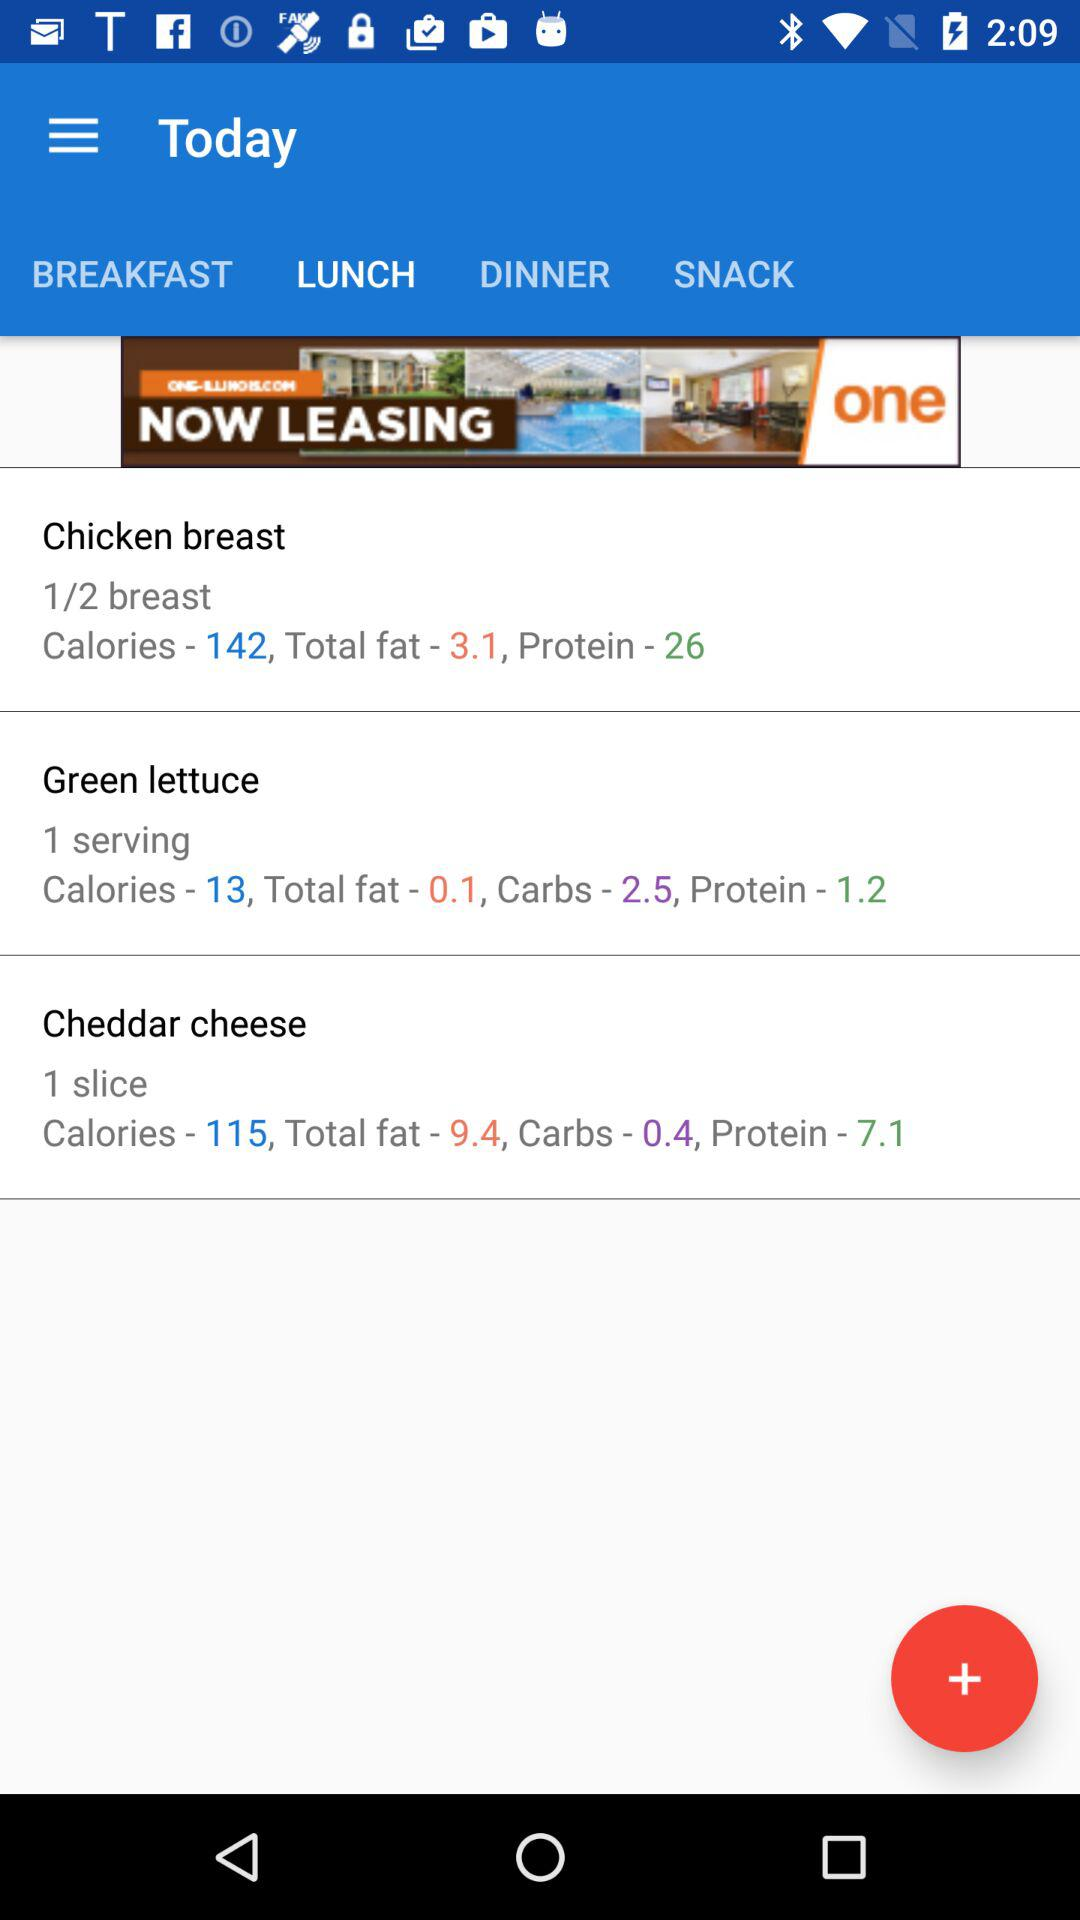What is the total amount of fat in "Chicken breast"? The total amount of fat in "Chicken breast" is 3.1. 